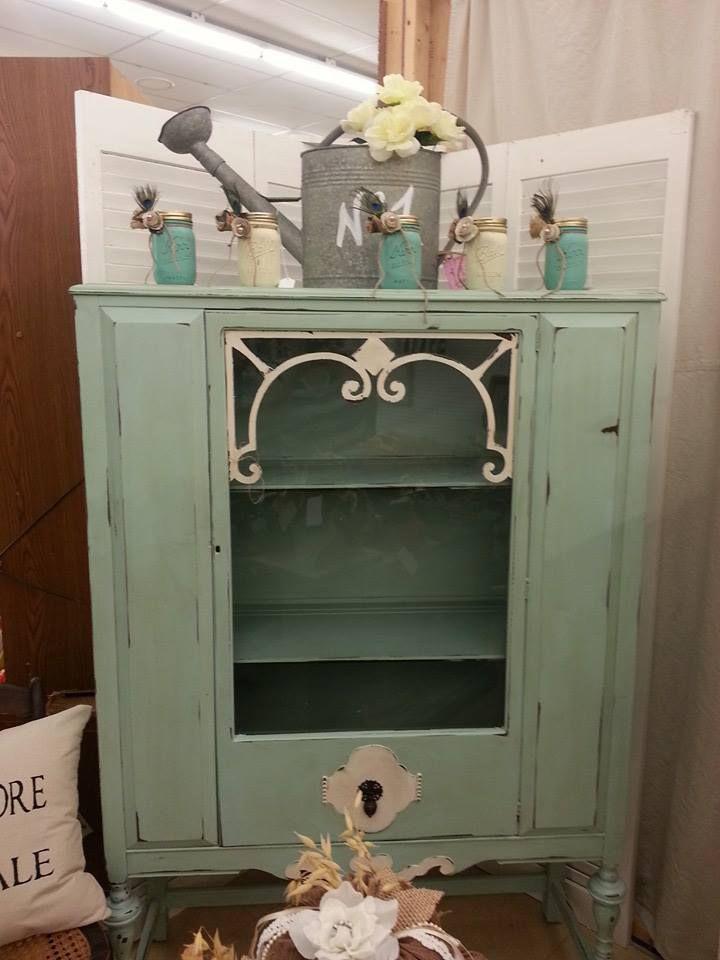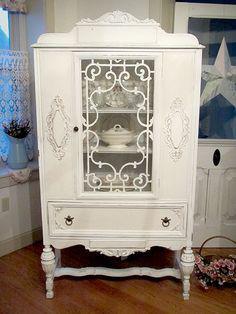The first image is the image on the left, the second image is the image on the right. For the images displayed, is the sentence "the right pic furniture piece has 3 or more glass panels" factually correct? Answer yes or no. No. The first image is the image on the left, the second image is the image on the right. Given the left and right images, does the statement "One of the cabinets is empty inside." hold true? Answer yes or no. Yes. 